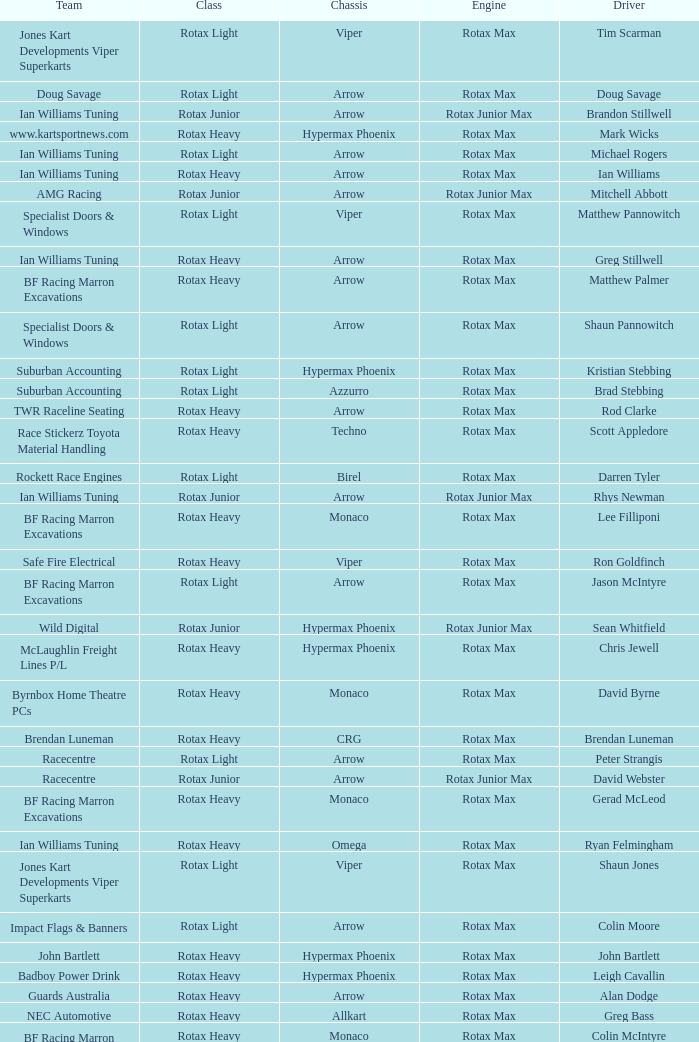What is the name of the driver with a rotax max engine, in the rotax heavy class, with arrow as chassis and on the TWR Raceline Seating team? Rod Clarke. 